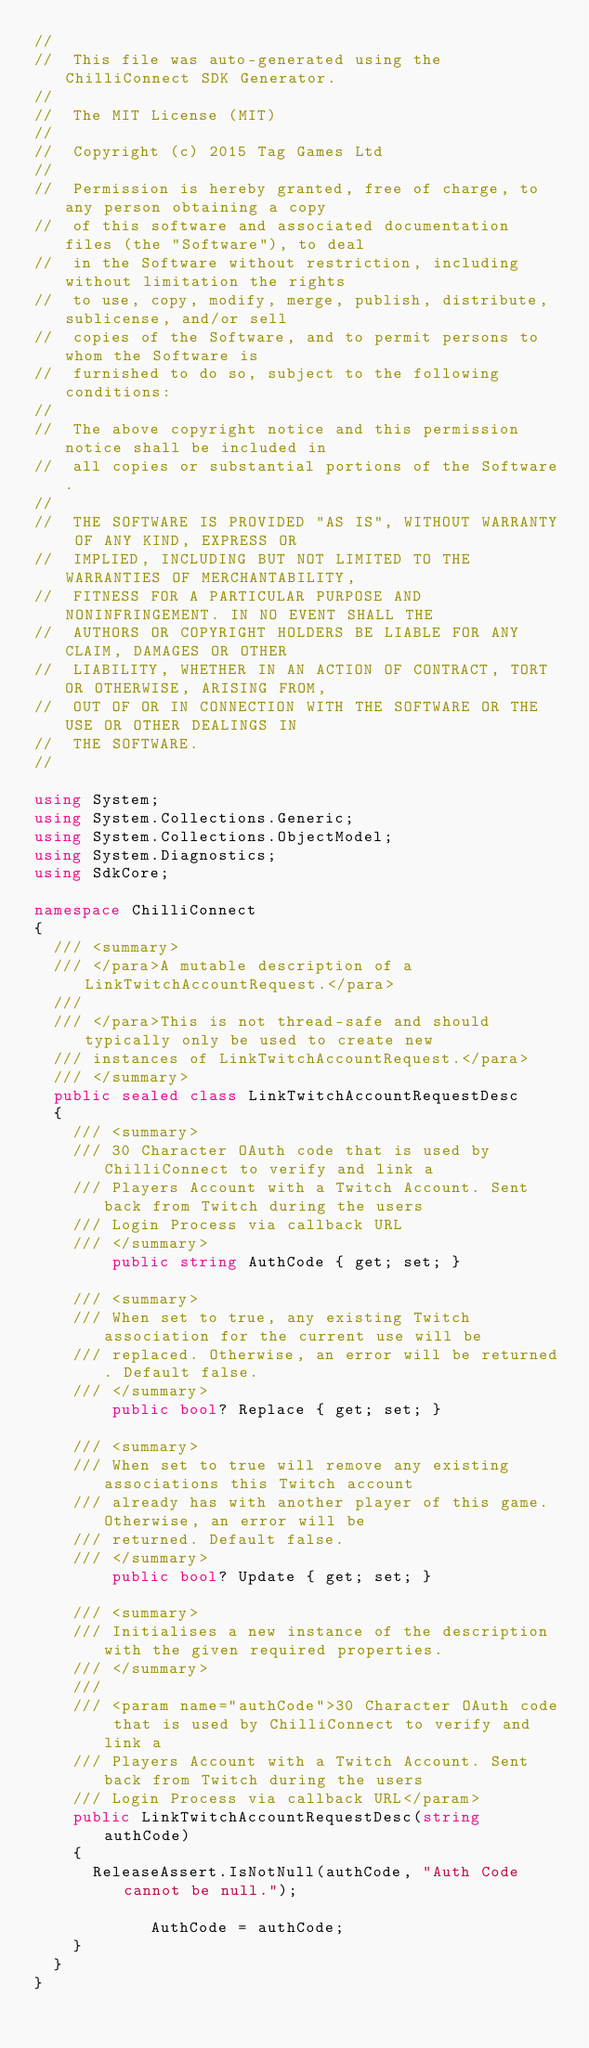<code> <loc_0><loc_0><loc_500><loc_500><_C#_>//
//  This file was auto-generated using the ChilliConnect SDK Generator.
//
//  The MIT License (MIT)
//
//  Copyright (c) 2015 Tag Games Ltd
//
//  Permission is hereby granted, free of charge, to any person obtaining a copy
//  of this software and associated documentation files (the "Software"), to deal
//  in the Software without restriction, including without limitation the rights
//  to use, copy, modify, merge, publish, distribute, sublicense, and/or sell
//  copies of the Software, and to permit persons to whom the Software is
//  furnished to do so, subject to the following conditions:
//
//  The above copyright notice and this permission notice shall be included in
//  all copies or substantial portions of the Software.
//
//  THE SOFTWARE IS PROVIDED "AS IS", WITHOUT WARRANTY OF ANY KIND, EXPRESS OR
//  IMPLIED, INCLUDING BUT NOT LIMITED TO THE WARRANTIES OF MERCHANTABILITY,
//  FITNESS FOR A PARTICULAR PURPOSE AND NONINFRINGEMENT. IN NO EVENT SHALL THE
//  AUTHORS OR COPYRIGHT HOLDERS BE LIABLE FOR ANY CLAIM, DAMAGES OR OTHER
//  LIABILITY, WHETHER IN AN ACTION OF CONTRACT, TORT OR OTHERWISE, ARISING FROM,
//  OUT OF OR IN CONNECTION WITH THE SOFTWARE OR THE USE OR OTHER DEALINGS IN
//  THE SOFTWARE.
//

using System;
using System.Collections.Generic;
using System.Collections.ObjectModel;
using System.Diagnostics;
using SdkCore;

namespace ChilliConnect
{
	/// <summary>
	/// </para>A mutable description of a LinkTwitchAccountRequest.</para>
	///
	/// </para>This is not thread-safe and should typically only be used to create new 
	/// instances of LinkTwitchAccountRequest.</para>
	/// </summary>
	public sealed class LinkTwitchAccountRequestDesc
	{
		/// <summary>
		/// 30 Character OAuth code that is used by ChilliConnect to verify and link a
		/// Players Account with a Twitch Account. Sent back from Twitch during the users
		/// Login Process via callback URL
		/// </summary>
        public string AuthCode { get; set; }
	
		/// <summary>
		/// When set to true, any existing Twitch association for the current use will be
		/// replaced. Otherwise, an error will be returned. Default false.
		/// </summary>
        public bool? Replace { get; set; }
	
		/// <summary>
		/// When set to true will remove any existing associations this Twitch account
		/// already has with another player of this game. Otherwise, an error will be
		/// returned. Default false.
		/// </summary>
        public bool? Update { get; set; }

		/// <summary>
		/// Initialises a new instance of the description with the given required properties.
		/// </summary>
		///
		/// <param name="authCode">30 Character OAuth code that is used by ChilliConnect to verify and link a
		/// Players Account with a Twitch Account. Sent back from Twitch during the users
		/// Login Process via callback URL</param>
		public LinkTwitchAccountRequestDesc(string authCode)
		{
			ReleaseAssert.IsNotNull(authCode, "Auth Code cannot be null.");
	
            AuthCode = authCode;
		}
	}
}
</code> 